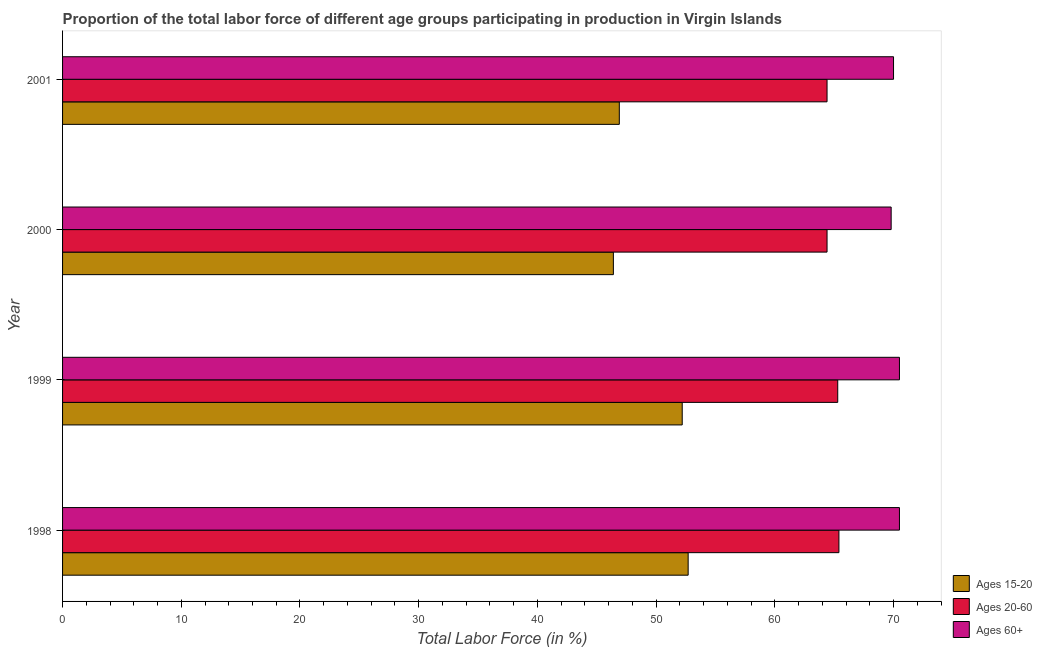What is the label of the 4th group of bars from the top?
Your answer should be very brief. 1998. What is the percentage of labor force within the age group 15-20 in 1998?
Your response must be concise. 52.7. Across all years, what is the maximum percentage of labor force within the age group 20-60?
Provide a short and direct response. 65.4. Across all years, what is the minimum percentage of labor force above age 60?
Give a very brief answer. 69.8. In which year was the percentage of labor force above age 60 minimum?
Give a very brief answer. 2000. What is the total percentage of labor force within the age group 20-60 in the graph?
Your answer should be compact. 259.5. What is the difference between the percentage of labor force within the age group 20-60 in 2000 and that in 2001?
Make the answer very short. 0. What is the difference between the percentage of labor force within the age group 20-60 in 2000 and the percentage of labor force above age 60 in 1999?
Offer a terse response. -6.1. What is the average percentage of labor force within the age group 20-60 per year?
Your answer should be compact. 64.88. What is the ratio of the percentage of labor force within the age group 20-60 in 1999 to that in 2000?
Give a very brief answer. 1.01. Is the percentage of labor force above age 60 in 1999 less than that in 2000?
Provide a short and direct response. No. In how many years, is the percentage of labor force above age 60 greater than the average percentage of labor force above age 60 taken over all years?
Provide a succinct answer. 2. Is the sum of the percentage of labor force within the age group 20-60 in 1999 and 2000 greater than the maximum percentage of labor force within the age group 15-20 across all years?
Keep it short and to the point. Yes. What does the 2nd bar from the top in 2001 represents?
Make the answer very short. Ages 20-60. What does the 2nd bar from the bottom in 1998 represents?
Provide a succinct answer. Ages 20-60. Is it the case that in every year, the sum of the percentage of labor force within the age group 15-20 and percentage of labor force within the age group 20-60 is greater than the percentage of labor force above age 60?
Your answer should be very brief. Yes. Are all the bars in the graph horizontal?
Your response must be concise. Yes. How many years are there in the graph?
Your answer should be compact. 4. Does the graph contain grids?
Ensure brevity in your answer.  No. How many legend labels are there?
Your response must be concise. 3. How are the legend labels stacked?
Offer a terse response. Vertical. What is the title of the graph?
Your response must be concise. Proportion of the total labor force of different age groups participating in production in Virgin Islands. Does "Ireland" appear as one of the legend labels in the graph?
Offer a terse response. No. What is the Total Labor Force (in %) in Ages 15-20 in 1998?
Ensure brevity in your answer.  52.7. What is the Total Labor Force (in %) in Ages 20-60 in 1998?
Keep it short and to the point. 65.4. What is the Total Labor Force (in %) of Ages 60+ in 1998?
Ensure brevity in your answer.  70.5. What is the Total Labor Force (in %) of Ages 15-20 in 1999?
Ensure brevity in your answer.  52.2. What is the Total Labor Force (in %) in Ages 20-60 in 1999?
Offer a very short reply. 65.3. What is the Total Labor Force (in %) of Ages 60+ in 1999?
Give a very brief answer. 70.5. What is the Total Labor Force (in %) in Ages 15-20 in 2000?
Offer a very short reply. 46.4. What is the Total Labor Force (in %) in Ages 20-60 in 2000?
Provide a succinct answer. 64.4. What is the Total Labor Force (in %) in Ages 60+ in 2000?
Provide a succinct answer. 69.8. What is the Total Labor Force (in %) of Ages 15-20 in 2001?
Give a very brief answer. 46.9. What is the Total Labor Force (in %) in Ages 20-60 in 2001?
Provide a succinct answer. 64.4. What is the Total Labor Force (in %) in Ages 60+ in 2001?
Keep it short and to the point. 70. Across all years, what is the maximum Total Labor Force (in %) in Ages 15-20?
Ensure brevity in your answer.  52.7. Across all years, what is the maximum Total Labor Force (in %) of Ages 20-60?
Your response must be concise. 65.4. Across all years, what is the maximum Total Labor Force (in %) of Ages 60+?
Your answer should be very brief. 70.5. Across all years, what is the minimum Total Labor Force (in %) of Ages 15-20?
Offer a very short reply. 46.4. Across all years, what is the minimum Total Labor Force (in %) of Ages 20-60?
Provide a succinct answer. 64.4. Across all years, what is the minimum Total Labor Force (in %) of Ages 60+?
Ensure brevity in your answer.  69.8. What is the total Total Labor Force (in %) of Ages 15-20 in the graph?
Keep it short and to the point. 198.2. What is the total Total Labor Force (in %) in Ages 20-60 in the graph?
Provide a succinct answer. 259.5. What is the total Total Labor Force (in %) in Ages 60+ in the graph?
Make the answer very short. 280.8. What is the difference between the Total Labor Force (in %) in Ages 15-20 in 1998 and that in 2000?
Provide a succinct answer. 6.3. What is the difference between the Total Labor Force (in %) of Ages 60+ in 1998 and that in 2000?
Provide a succinct answer. 0.7. What is the difference between the Total Labor Force (in %) of Ages 15-20 in 1998 and that in 2001?
Ensure brevity in your answer.  5.8. What is the difference between the Total Labor Force (in %) of Ages 15-20 in 1999 and that in 2000?
Your answer should be very brief. 5.8. What is the difference between the Total Labor Force (in %) of Ages 60+ in 1999 and that in 2000?
Give a very brief answer. 0.7. What is the difference between the Total Labor Force (in %) of Ages 15-20 in 1999 and that in 2001?
Keep it short and to the point. 5.3. What is the difference between the Total Labor Force (in %) of Ages 60+ in 1999 and that in 2001?
Ensure brevity in your answer.  0.5. What is the difference between the Total Labor Force (in %) of Ages 60+ in 2000 and that in 2001?
Keep it short and to the point. -0.2. What is the difference between the Total Labor Force (in %) of Ages 15-20 in 1998 and the Total Labor Force (in %) of Ages 60+ in 1999?
Provide a short and direct response. -17.8. What is the difference between the Total Labor Force (in %) of Ages 15-20 in 1998 and the Total Labor Force (in %) of Ages 60+ in 2000?
Your response must be concise. -17.1. What is the difference between the Total Labor Force (in %) of Ages 15-20 in 1998 and the Total Labor Force (in %) of Ages 60+ in 2001?
Your response must be concise. -17.3. What is the difference between the Total Labor Force (in %) in Ages 20-60 in 1998 and the Total Labor Force (in %) in Ages 60+ in 2001?
Make the answer very short. -4.6. What is the difference between the Total Labor Force (in %) of Ages 15-20 in 1999 and the Total Labor Force (in %) of Ages 20-60 in 2000?
Give a very brief answer. -12.2. What is the difference between the Total Labor Force (in %) in Ages 15-20 in 1999 and the Total Labor Force (in %) in Ages 60+ in 2000?
Provide a succinct answer. -17.6. What is the difference between the Total Labor Force (in %) in Ages 15-20 in 1999 and the Total Labor Force (in %) in Ages 20-60 in 2001?
Offer a very short reply. -12.2. What is the difference between the Total Labor Force (in %) in Ages 15-20 in 1999 and the Total Labor Force (in %) in Ages 60+ in 2001?
Provide a succinct answer. -17.8. What is the difference between the Total Labor Force (in %) in Ages 20-60 in 1999 and the Total Labor Force (in %) in Ages 60+ in 2001?
Keep it short and to the point. -4.7. What is the difference between the Total Labor Force (in %) in Ages 15-20 in 2000 and the Total Labor Force (in %) in Ages 60+ in 2001?
Make the answer very short. -23.6. What is the average Total Labor Force (in %) of Ages 15-20 per year?
Offer a very short reply. 49.55. What is the average Total Labor Force (in %) in Ages 20-60 per year?
Make the answer very short. 64.88. What is the average Total Labor Force (in %) of Ages 60+ per year?
Give a very brief answer. 70.2. In the year 1998, what is the difference between the Total Labor Force (in %) in Ages 15-20 and Total Labor Force (in %) in Ages 60+?
Give a very brief answer. -17.8. In the year 1998, what is the difference between the Total Labor Force (in %) in Ages 20-60 and Total Labor Force (in %) in Ages 60+?
Your answer should be compact. -5.1. In the year 1999, what is the difference between the Total Labor Force (in %) of Ages 15-20 and Total Labor Force (in %) of Ages 60+?
Provide a succinct answer. -18.3. In the year 2000, what is the difference between the Total Labor Force (in %) in Ages 15-20 and Total Labor Force (in %) in Ages 20-60?
Ensure brevity in your answer.  -18. In the year 2000, what is the difference between the Total Labor Force (in %) of Ages 15-20 and Total Labor Force (in %) of Ages 60+?
Give a very brief answer. -23.4. In the year 2001, what is the difference between the Total Labor Force (in %) in Ages 15-20 and Total Labor Force (in %) in Ages 20-60?
Make the answer very short. -17.5. In the year 2001, what is the difference between the Total Labor Force (in %) in Ages 15-20 and Total Labor Force (in %) in Ages 60+?
Ensure brevity in your answer.  -23.1. In the year 2001, what is the difference between the Total Labor Force (in %) in Ages 20-60 and Total Labor Force (in %) in Ages 60+?
Provide a succinct answer. -5.6. What is the ratio of the Total Labor Force (in %) in Ages 15-20 in 1998 to that in 1999?
Give a very brief answer. 1.01. What is the ratio of the Total Labor Force (in %) of Ages 20-60 in 1998 to that in 1999?
Offer a terse response. 1. What is the ratio of the Total Labor Force (in %) of Ages 15-20 in 1998 to that in 2000?
Offer a terse response. 1.14. What is the ratio of the Total Labor Force (in %) in Ages 20-60 in 1998 to that in 2000?
Your response must be concise. 1.02. What is the ratio of the Total Labor Force (in %) of Ages 60+ in 1998 to that in 2000?
Your response must be concise. 1.01. What is the ratio of the Total Labor Force (in %) of Ages 15-20 in 1998 to that in 2001?
Your response must be concise. 1.12. What is the ratio of the Total Labor Force (in %) in Ages 20-60 in 1998 to that in 2001?
Ensure brevity in your answer.  1.02. What is the ratio of the Total Labor Force (in %) in Ages 60+ in 1998 to that in 2001?
Make the answer very short. 1.01. What is the ratio of the Total Labor Force (in %) in Ages 15-20 in 1999 to that in 2000?
Keep it short and to the point. 1.12. What is the ratio of the Total Labor Force (in %) of Ages 20-60 in 1999 to that in 2000?
Provide a short and direct response. 1.01. What is the ratio of the Total Labor Force (in %) in Ages 15-20 in 1999 to that in 2001?
Your response must be concise. 1.11. What is the ratio of the Total Labor Force (in %) of Ages 60+ in 1999 to that in 2001?
Provide a short and direct response. 1.01. What is the ratio of the Total Labor Force (in %) in Ages 15-20 in 2000 to that in 2001?
Your answer should be very brief. 0.99. What is the ratio of the Total Labor Force (in %) of Ages 60+ in 2000 to that in 2001?
Give a very brief answer. 1. What is the difference between the highest and the second highest Total Labor Force (in %) in Ages 15-20?
Offer a terse response. 0.5. 